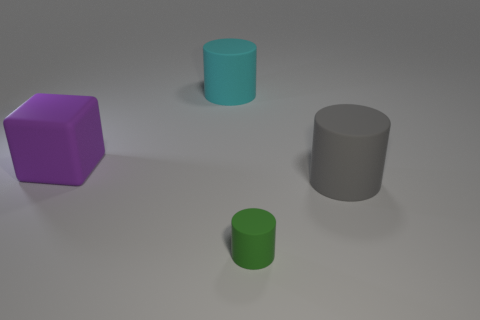Subtract all large cylinders. How many cylinders are left? 1 Subtract all green cylinders. How many cylinders are left? 2 Add 1 green objects. How many objects exist? 5 Subtract all cylinders. How many objects are left? 1 Subtract 1 cylinders. How many cylinders are left? 2 Subtract all red cylinders. Subtract all blue balls. How many cylinders are left? 3 Subtract all gray cylinders. How many cyan blocks are left? 0 Subtract all small brown rubber blocks. Subtract all blocks. How many objects are left? 3 Add 1 gray matte cylinders. How many gray matte cylinders are left? 2 Add 2 large blocks. How many large blocks exist? 3 